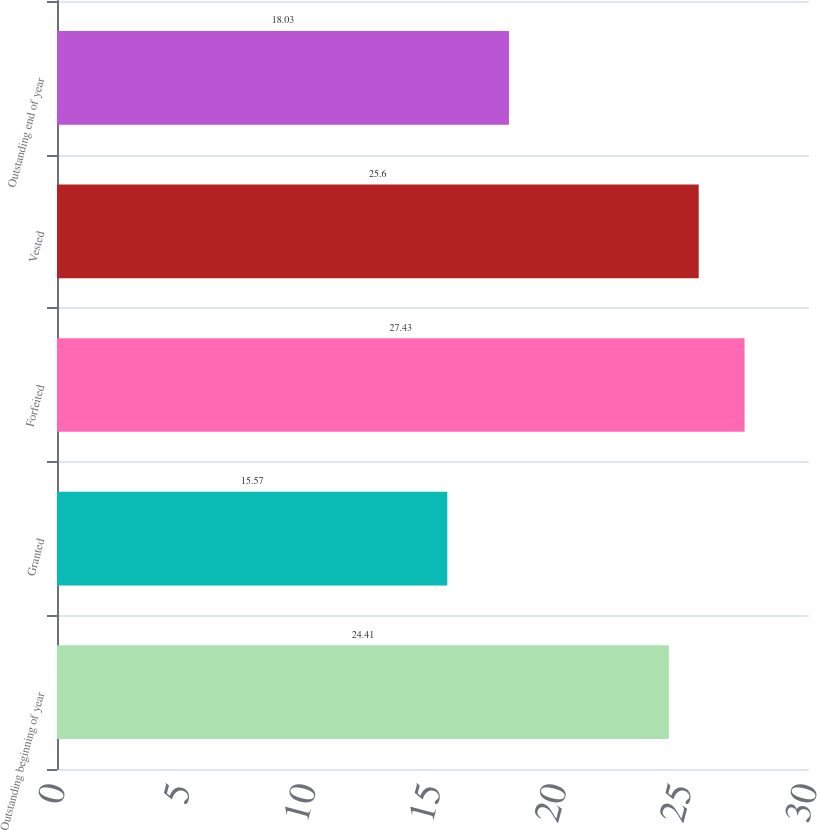<chart> <loc_0><loc_0><loc_500><loc_500><bar_chart><fcel>Outstanding beginning of year<fcel>Granted<fcel>Forfeited<fcel>Vested<fcel>Outstanding end of year<nl><fcel>24.41<fcel>15.57<fcel>27.43<fcel>25.6<fcel>18.03<nl></chart> 